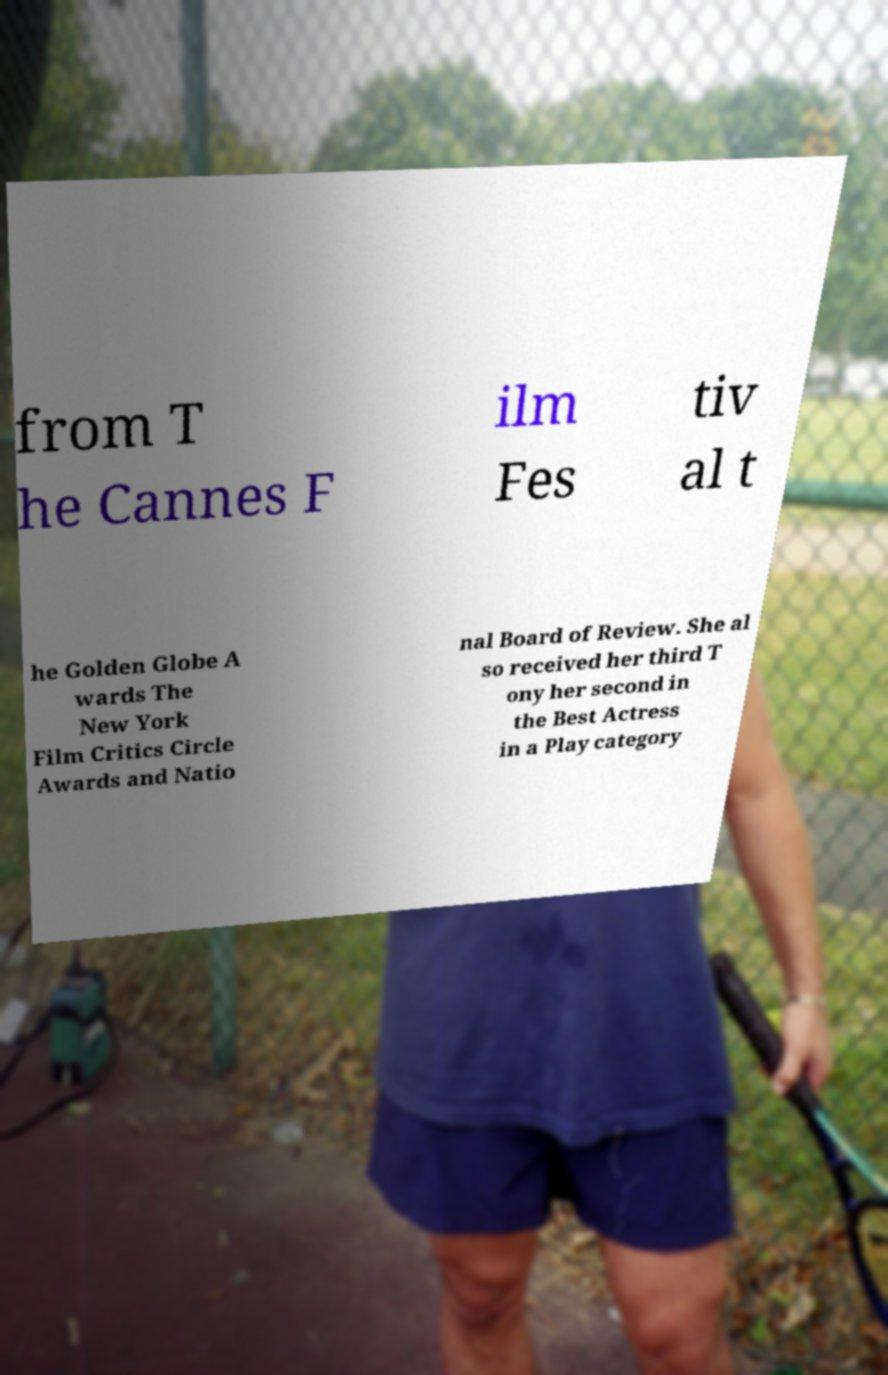Can you accurately transcribe the text from the provided image for me? from T he Cannes F ilm Fes tiv al t he Golden Globe A wards The New York Film Critics Circle Awards and Natio nal Board of Review. She al so received her third T ony her second in the Best Actress in a Play category 